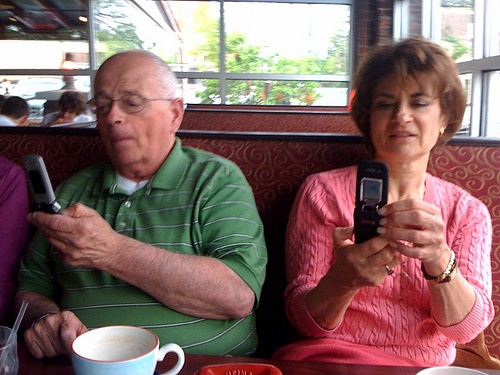Describe the objects in this image and their specific colors. I can see people in black, maroon, brown, and lightpink tones, people in black, brown, gray, and darkgreen tones, couch in black, brown, and maroon tones, dining table in black, maroon, white, and darkgray tones, and cup in black, white, darkgray, lightblue, and gray tones in this image. 